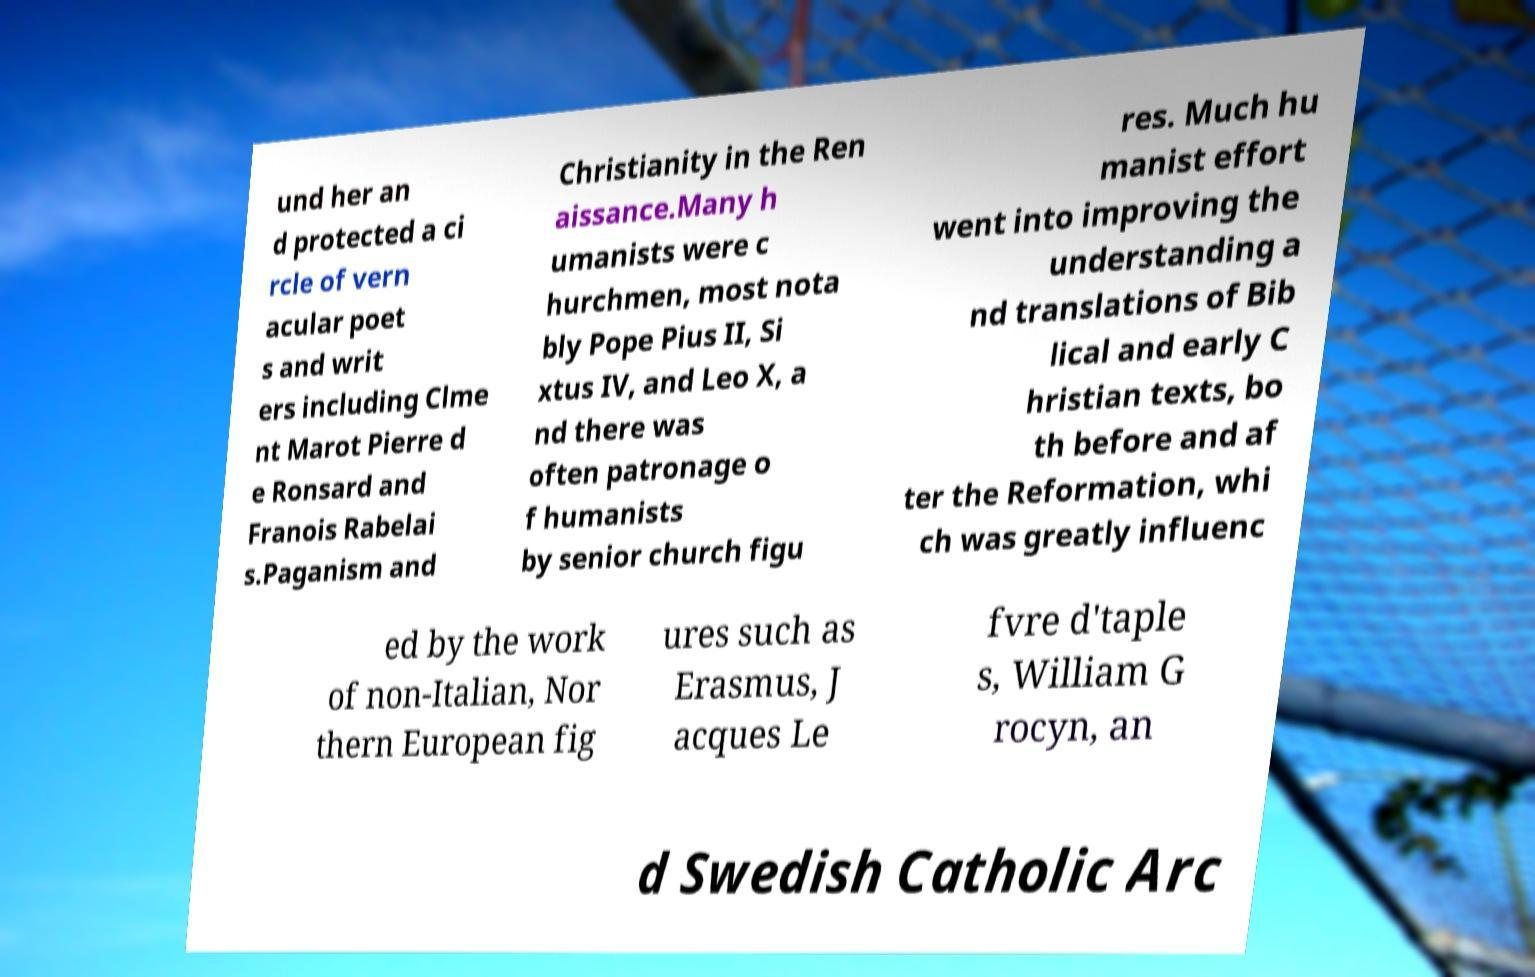Could you extract and type out the text from this image? und her an d protected a ci rcle of vern acular poet s and writ ers including Clme nt Marot Pierre d e Ronsard and Franois Rabelai s.Paganism and Christianity in the Ren aissance.Many h umanists were c hurchmen, most nota bly Pope Pius II, Si xtus IV, and Leo X, a nd there was often patronage o f humanists by senior church figu res. Much hu manist effort went into improving the understanding a nd translations of Bib lical and early C hristian texts, bo th before and af ter the Reformation, whi ch was greatly influenc ed by the work of non-Italian, Nor thern European fig ures such as Erasmus, J acques Le fvre d'taple s, William G rocyn, an d Swedish Catholic Arc 